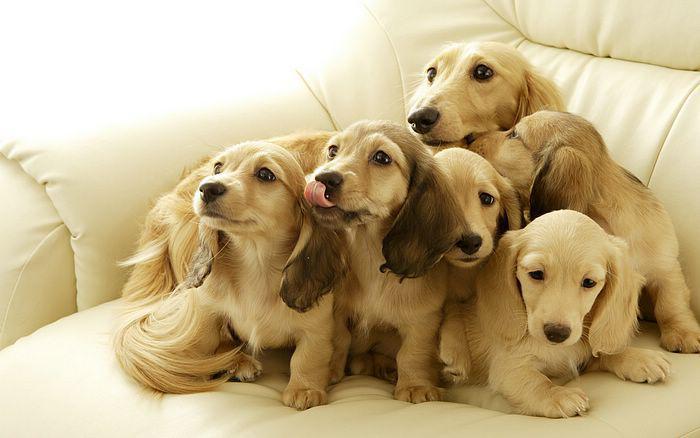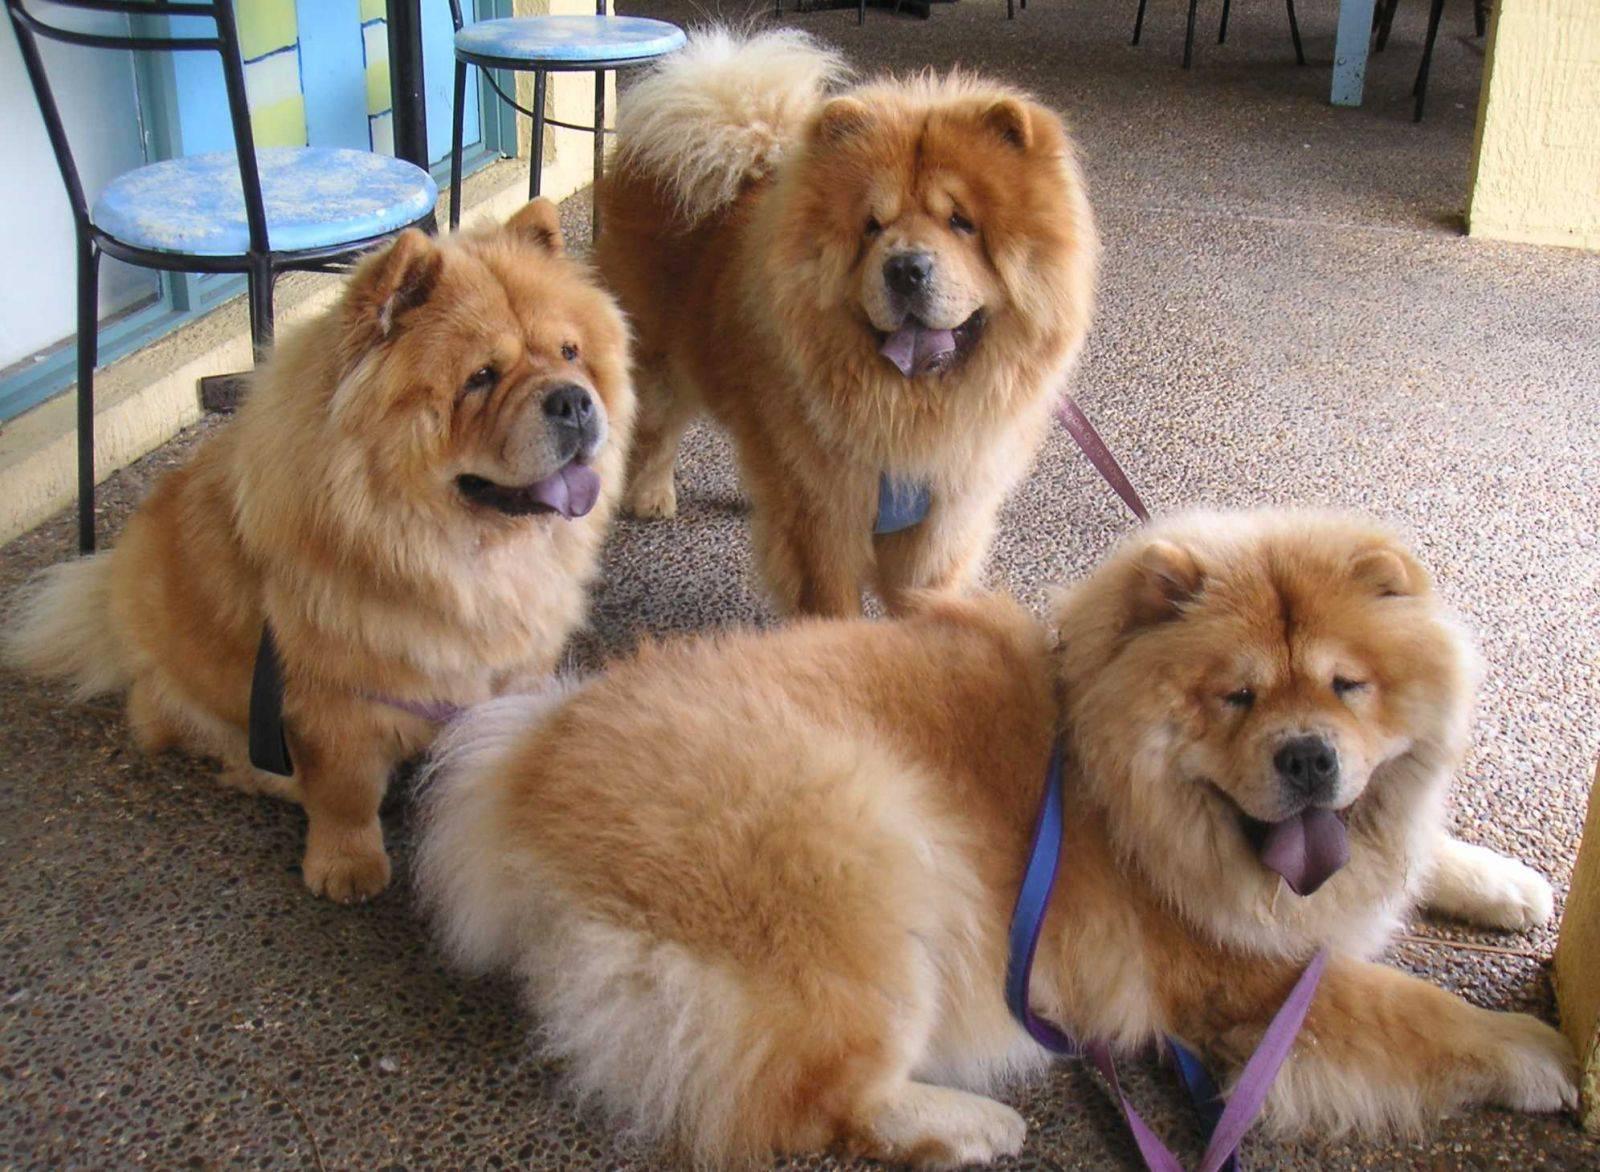The first image is the image on the left, the second image is the image on the right. For the images shown, is this caption "There is a dog with a stuffed animal in the image on the left." true? Answer yes or no. No. 